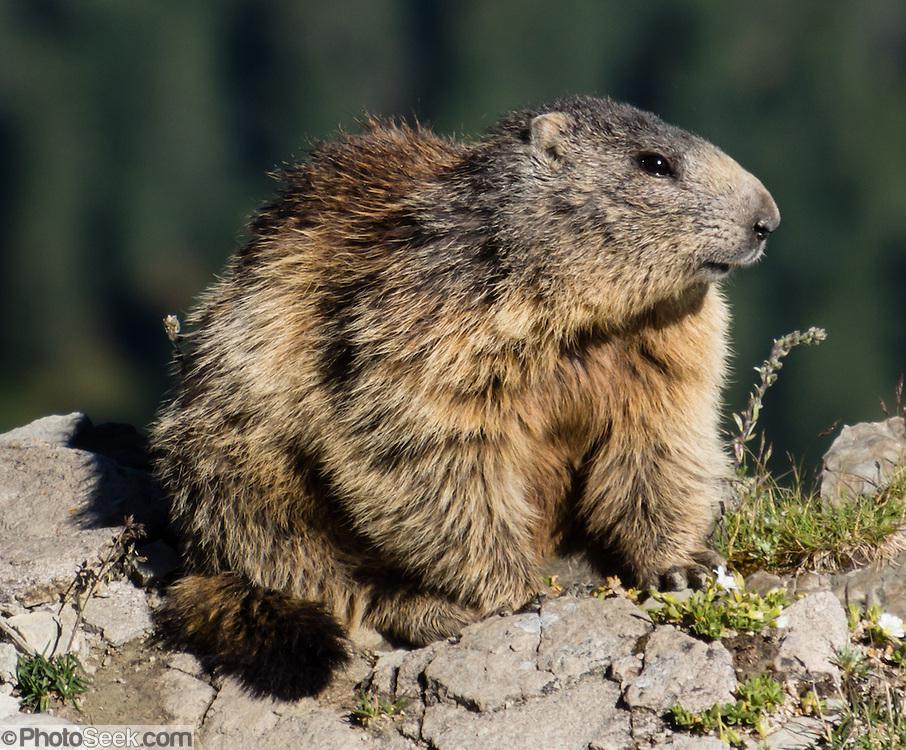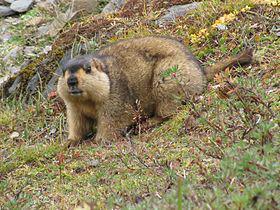The first image is the image on the left, the second image is the image on the right. Examine the images to the left and right. Is the description "In each image, there are at least two animals." accurate? Answer yes or no. No. 